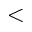Convert formula to latex. <formula><loc_0><loc_0><loc_500><loc_500><</formula> 